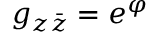<formula> <loc_0><loc_0><loc_500><loc_500>g _ { z \bar { z } } = e ^ { \varphi }</formula> 